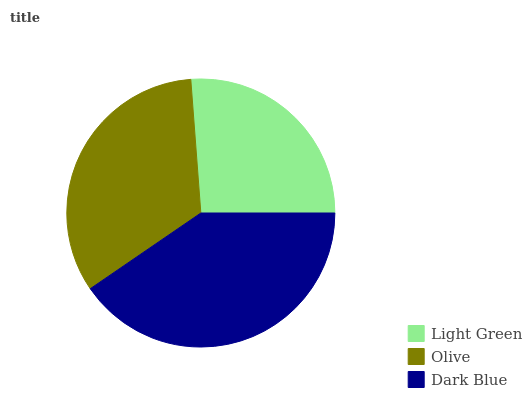Is Light Green the minimum?
Answer yes or no. Yes. Is Dark Blue the maximum?
Answer yes or no. Yes. Is Olive the minimum?
Answer yes or no. No. Is Olive the maximum?
Answer yes or no. No. Is Olive greater than Light Green?
Answer yes or no. Yes. Is Light Green less than Olive?
Answer yes or no. Yes. Is Light Green greater than Olive?
Answer yes or no. No. Is Olive less than Light Green?
Answer yes or no. No. Is Olive the high median?
Answer yes or no. Yes. Is Olive the low median?
Answer yes or no. Yes. Is Light Green the high median?
Answer yes or no. No. Is Dark Blue the low median?
Answer yes or no. No. 